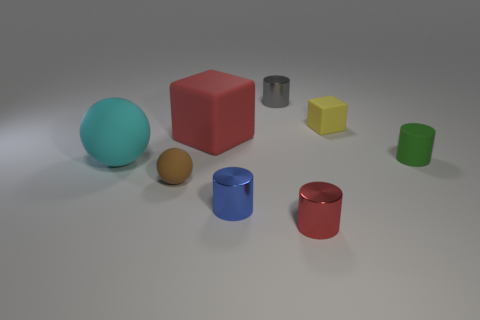Is the shape of the cyan matte object the same as the small metallic thing on the left side of the tiny gray metallic object?
Offer a very short reply. No. What material is the cylinder behind the matte thing behind the red matte cube?
Keep it short and to the point. Metal. Are there the same number of large red blocks to the right of the tiny green rubber object and small yellow metal things?
Offer a terse response. Yes. Are there any other things that have the same material as the small green cylinder?
Give a very brief answer. Yes. Does the big thing that is behind the green rubber object have the same color as the metallic object to the right of the small gray cylinder?
Your answer should be compact. Yes. How many objects are in front of the cyan thing and on the left side of the big matte cube?
Keep it short and to the point. 1. What number of other objects are the same shape as the blue shiny object?
Make the answer very short. 3. Are there more big red things to the right of the large sphere than big brown spheres?
Offer a terse response. Yes. What is the color of the shiny cylinder that is on the right side of the gray shiny cylinder?
Your response must be concise. Red. What is the size of the shiny cylinder that is the same color as the big rubber cube?
Your response must be concise. Small. 